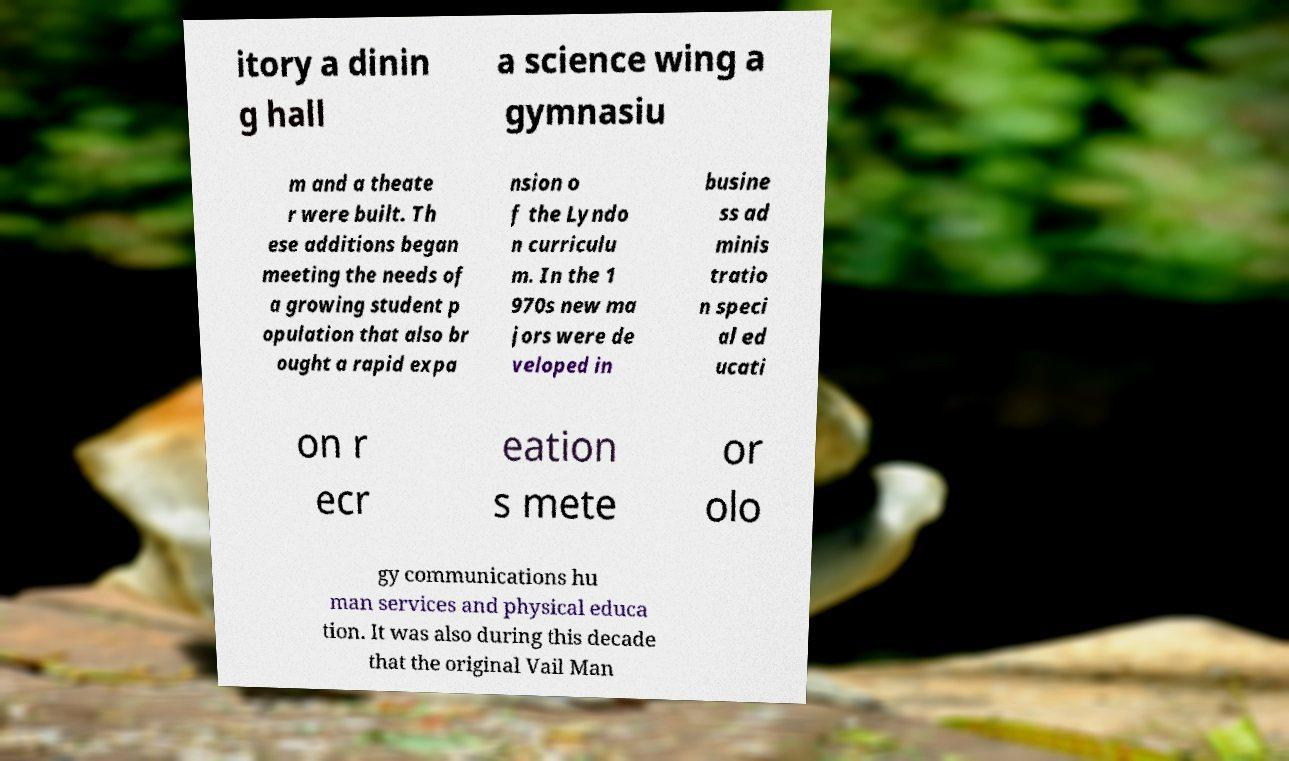Please read and relay the text visible in this image. What does it say? itory a dinin g hall a science wing a gymnasiu m and a theate r were built. Th ese additions began meeting the needs of a growing student p opulation that also br ought a rapid expa nsion o f the Lyndo n curriculu m. In the 1 970s new ma jors were de veloped in busine ss ad minis tratio n speci al ed ucati on r ecr eation s mete or olo gy communications hu man services and physical educa tion. It was also during this decade that the original Vail Man 